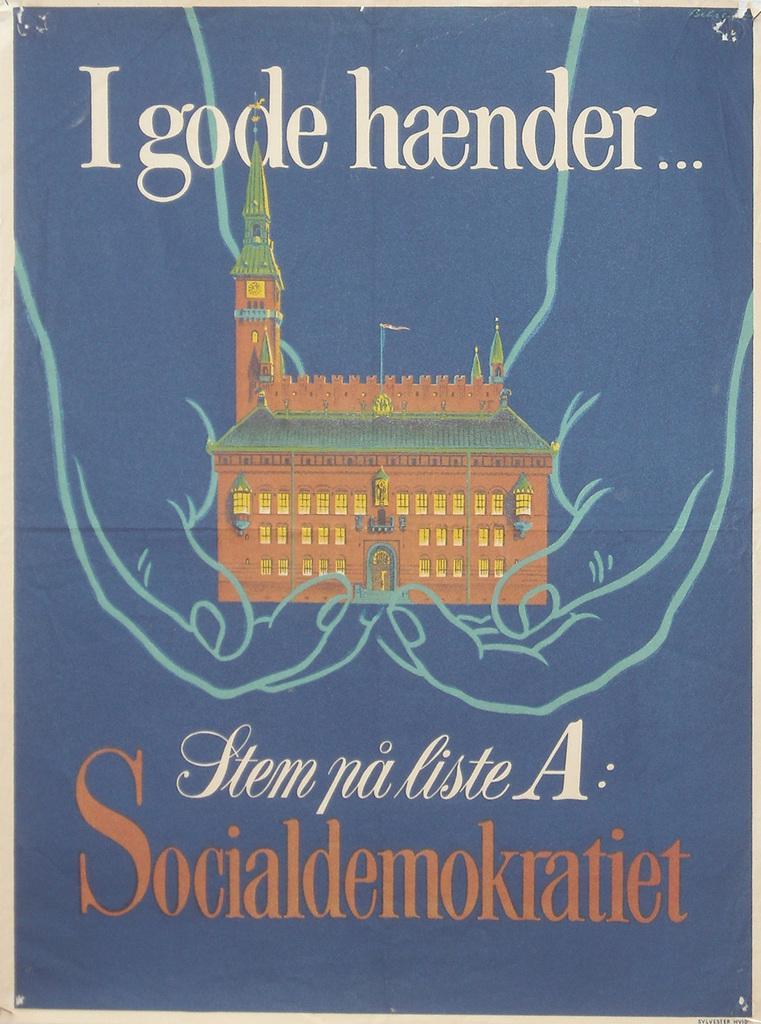In one or two sentences, can you explain what this image depicts? In this image, we can see hands holding a building. There is a text at the top and at the bottom of the image. 